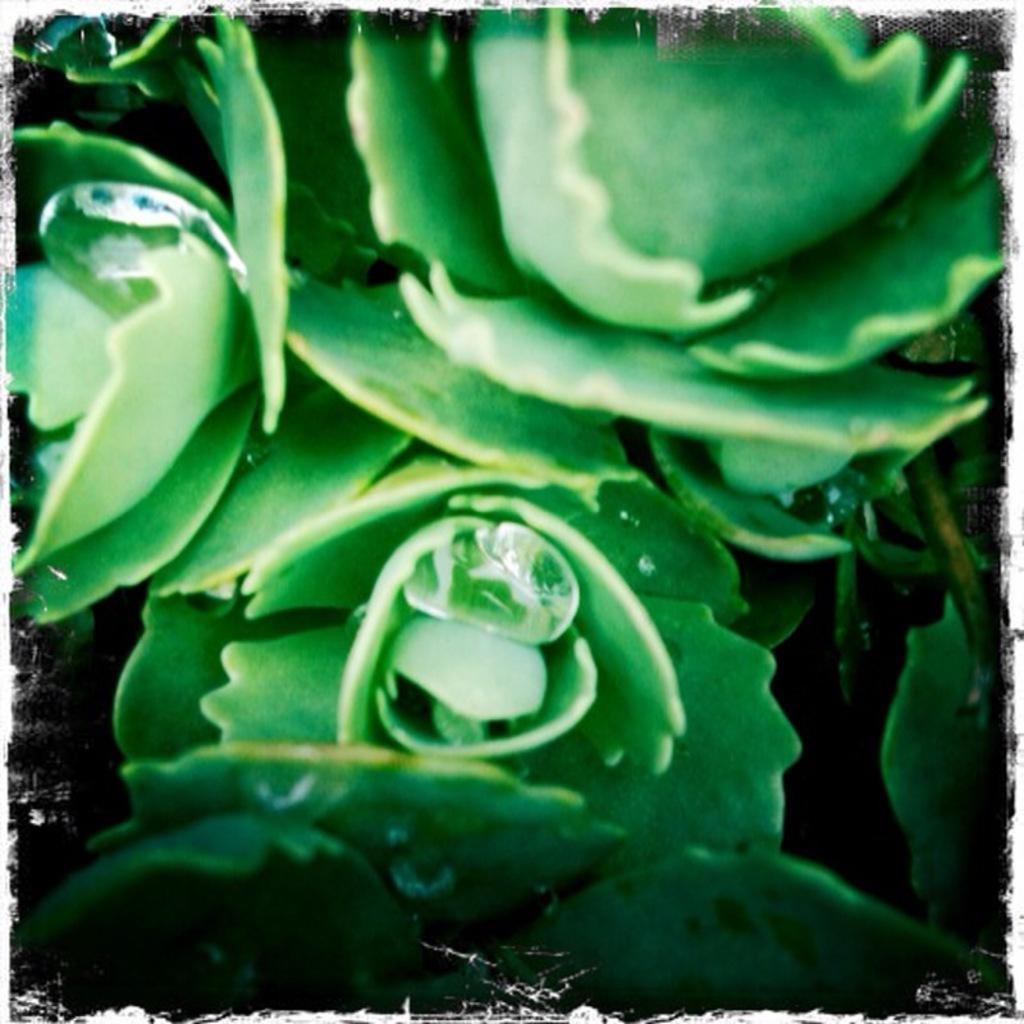Describe this image in one or two sentences. In this image we can see a plant. 